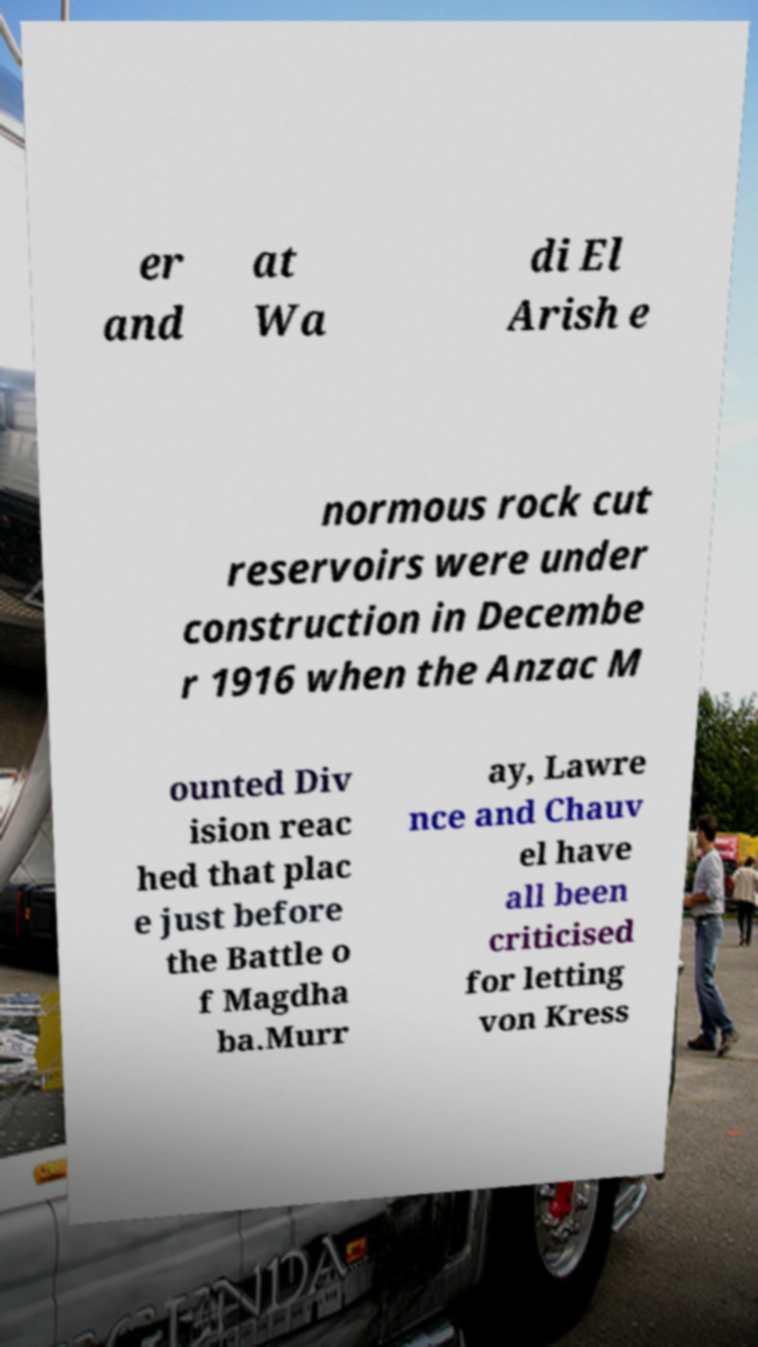For documentation purposes, I need the text within this image transcribed. Could you provide that? er and at Wa di El Arish e normous rock cut reservoirs were under construction in Decembe r 1916 when the Anzac M ounted Div ision reac hed that plac e just before the Battle o f Magdha ba.Murr ay, Lawre nce and Chauv el have all been criticised for letting von Kress 